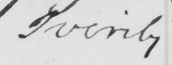What is written in this line of handwriting? verily 